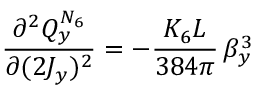<formula> <loc_0><loc_0><loc_500><loc_500>\frac { \partial ^ { 2 } Q _ { y } ^ { N _ { 6 } } } { \partial ( 2 J _ { y } ) ^ { 2 } } = - \frac { K _ { 6 } L } { 3 8 4 \pi } \, \beta _ { y } ^ { 3 }</formula> 